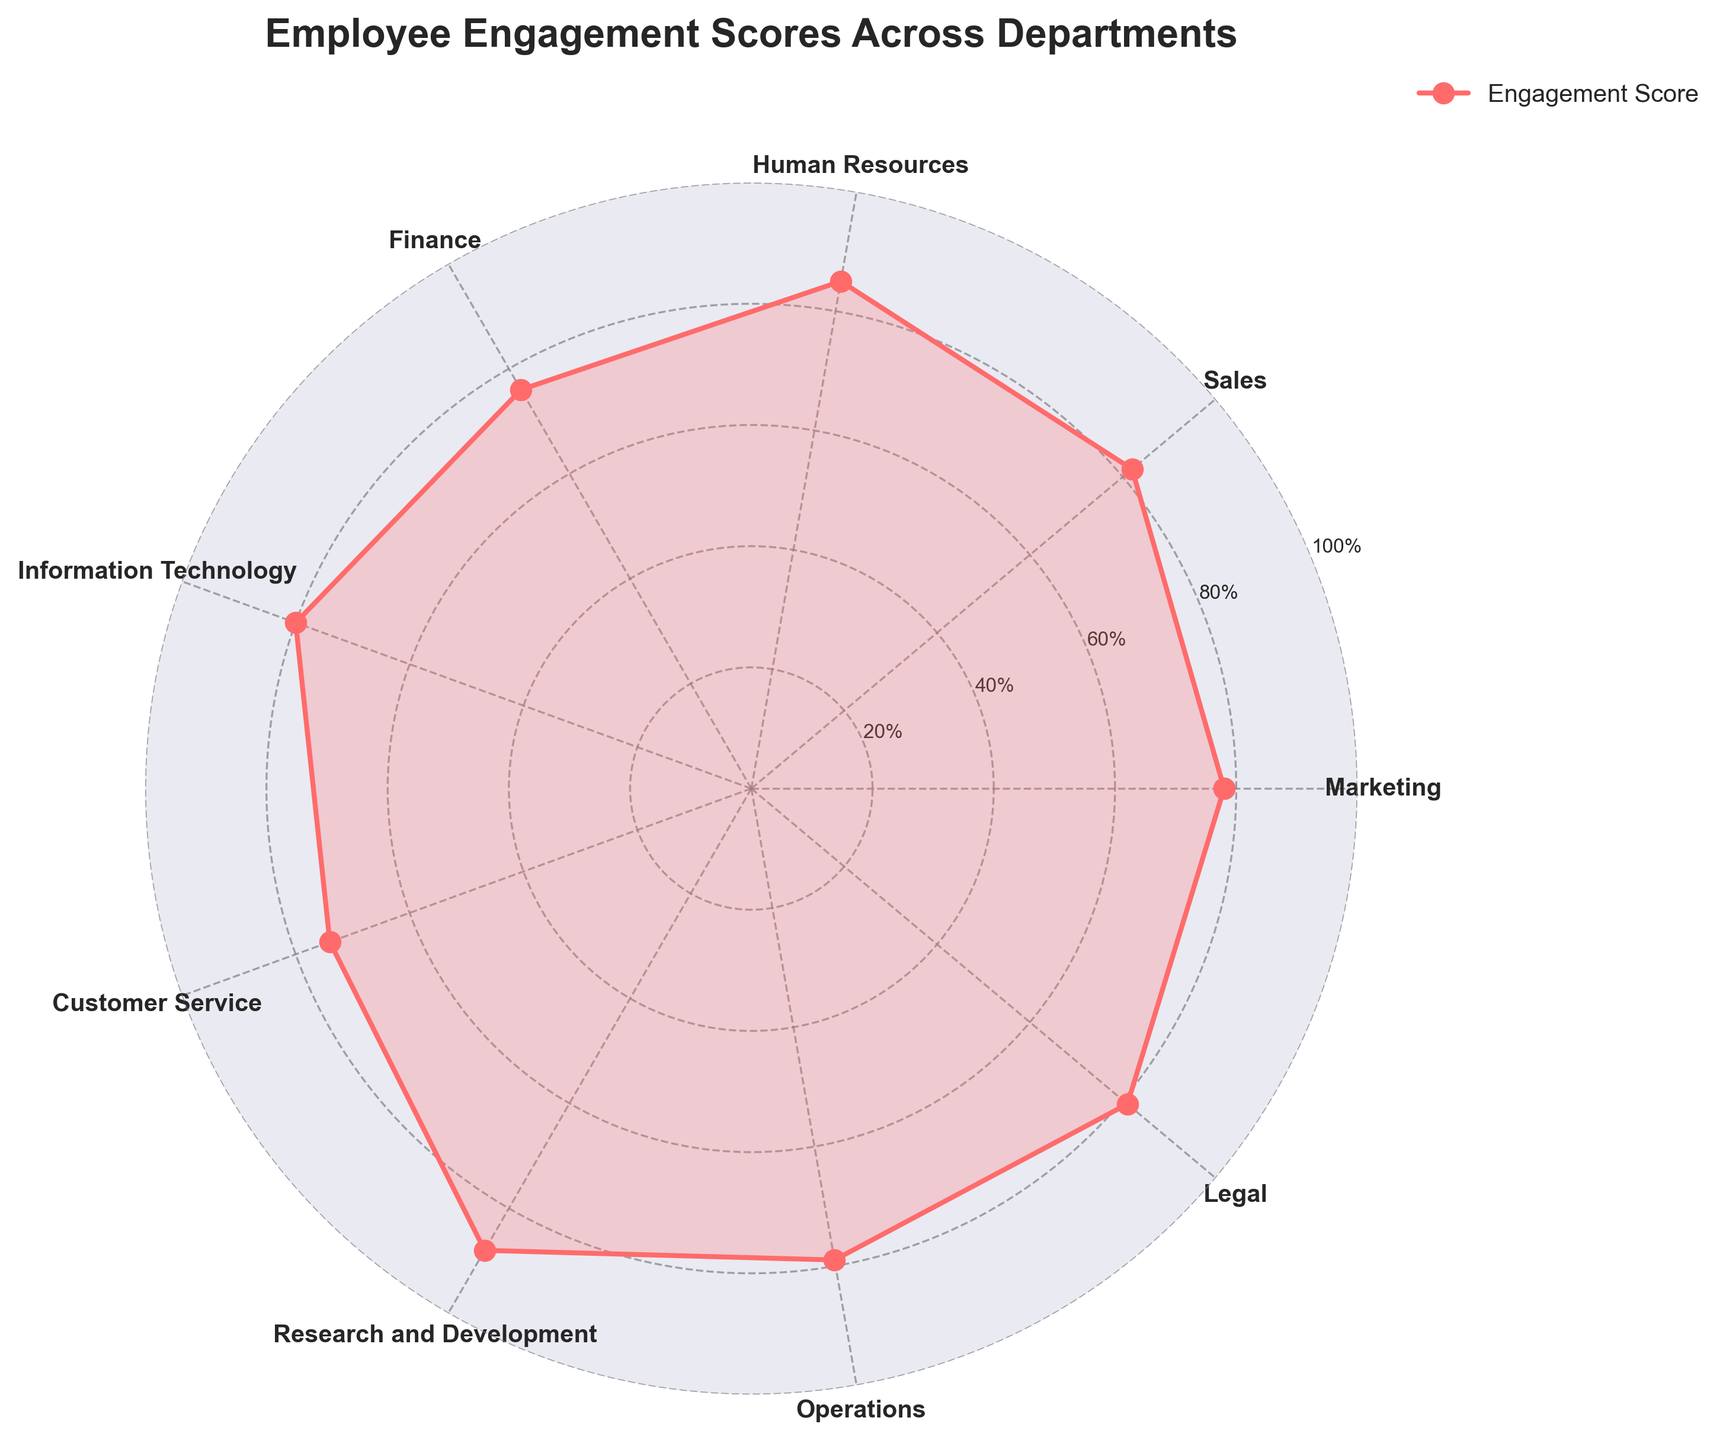What's the title of the figure? The title is typically placed at the top of the plot, often in a larger and bold font. It's the most straightforward element to spot.
Answer: "Employee Engagement Scores Across Departments" How many departments are included in the chart? Count each labeled sector around the polar chart. Each one represents a department.
Answer: 9 Which department has the highest engagement score? Look for the point furthest from the center of the polar chart. The corresponding label is the department with the highest engagement score.
Answer: Research and Development What is the engagement score of the Customer Service department? Locate the "Customer Service" label and trace the position of the point corresponding to it. Read the value along the radial axis.
Answer: 74 What is the difference in engagement scores between Sales and Finance departments? Find the scores for both Sales (82) and Finance (76). Subtract the lower score from the higher one.
Answer: 6 Which department has the lowest engagement score? Identify the point closest to the center of the polar chart. The corresponding label represents the department with the lowest engagement score.
Answer: Customer Service What is the average engagement score across all departments? Add all engagement scores and divide by the number of departments. The total is (78 + 82 + 85 + 76 + 80 + 74 + 88 + 79 + 81) = 723. Divide by 9.
Answer: 80.33 Compare the engagement scores of HR and IT departments. Which one is higher and by how much? Locate the scores for both Human Resources (85) and Information Technology (80). Subtract the lower from the higher.
Answer: HR is higher by 5 Is the engagement score of the Legal department greater than the average engagement score? Calculate the average score first (80.33). Compare the Legal department's score (81) to this average.
Answer: Yes Which departments have engagement scores above 80? Identify all points exceeding the 80% radial line and check their corresponding labels.
Answer: Sales, Human Resources, Research and Development, Legal 